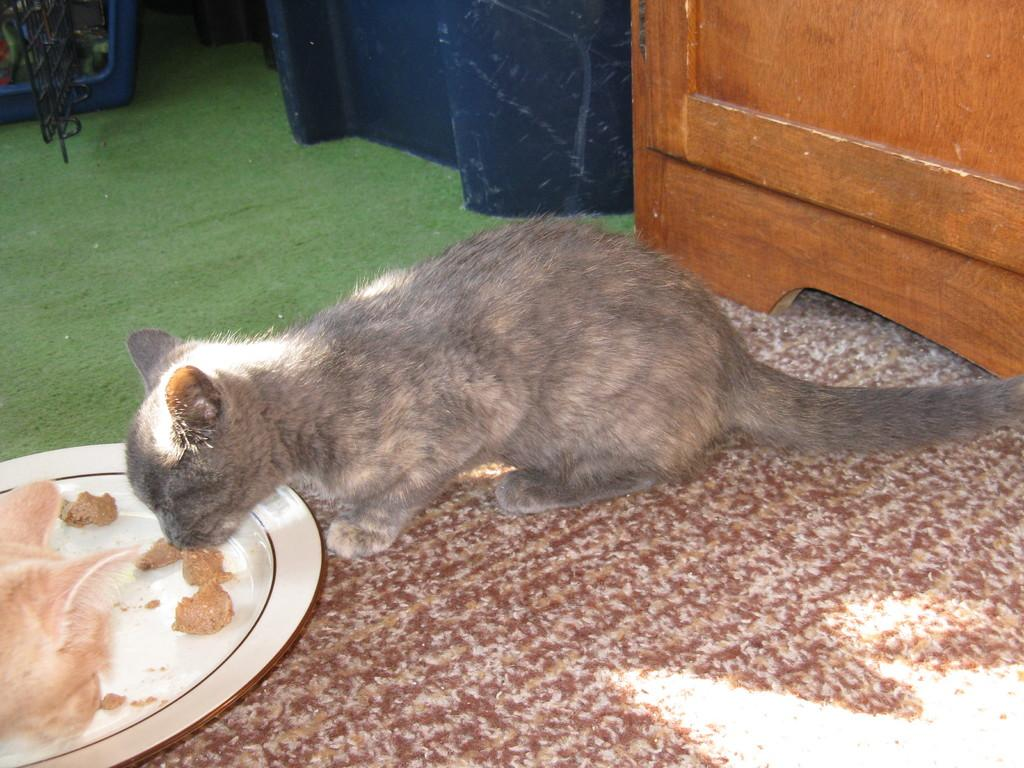How many cats are in the image? There are two cats in the image. What are the cats doing in the image? The cats are eating food in the image. Can you describe any objects visible in the background of the image? Unfortunately, the provided facts do not mention any specific objects in the background. What type of lace can be seen on the sack in the image? There is no sack or lace present in the image. What form does the cats' food take in the image? The provided facts do not specify the form of the cats' food, so we cannot answer this question definitively. 